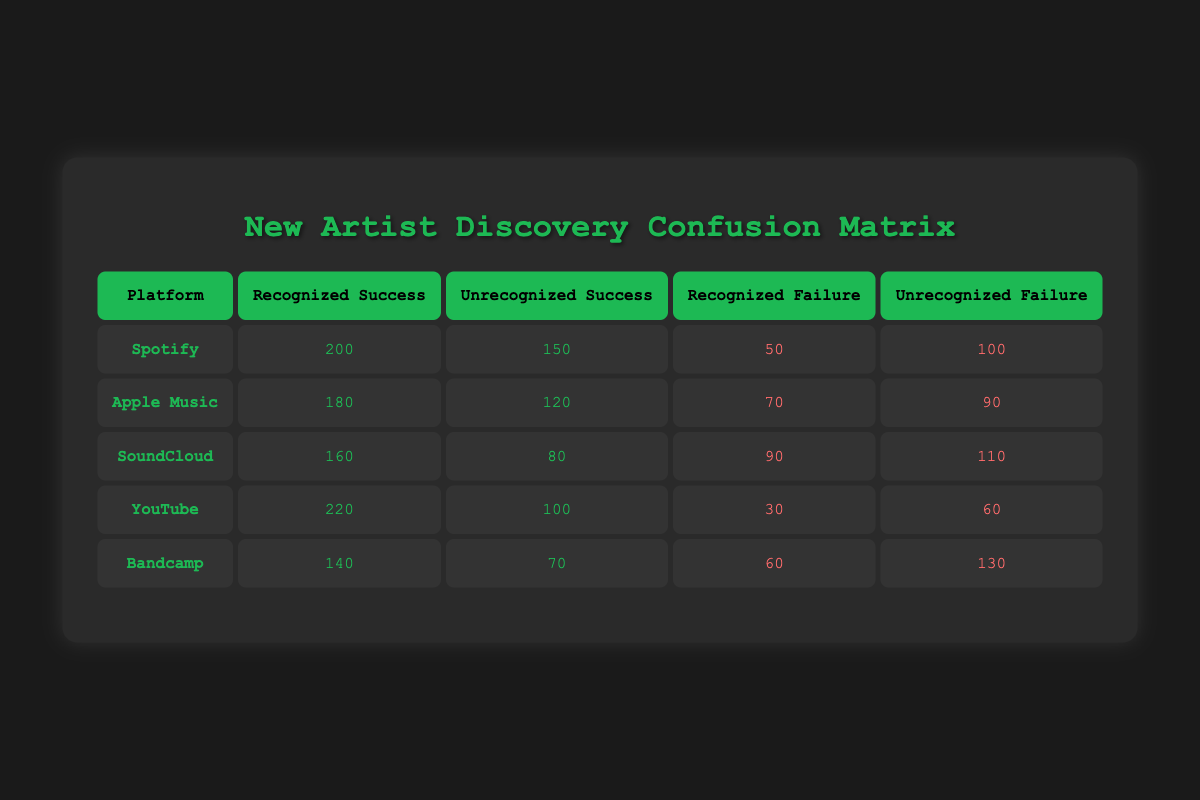What is the recognized success rate for Spotify? The recognized success for Spotify is 200, while the recognized failure is 50. To find the recognized success rate, divide recognized success by the total of recognized cases, which is 200/(200+50) = 200/250 = 0.8, meaning the recognized success rate for Spotify is 80%.
Answer: 80% How many total unsuccessful artist discoveries did Apple Music have? For Apple Music, recognized failure is 70 and unrecognized failure is 90. To find the total unsuccessful discoveries, add these two values: 70 + 90 = 160.
Answer: 160 Which platform had the highest number of recognized successful discoveries? Looking at the table, Spotify has 200 recognized successes, Apple Music has 180, SoundCloud has 160, YouTube has 220, and Bandcamp has 140. YouTube has the highest number at 220 recognized successes.
Answer: YouTube What is the average number of unrecognized successes across all platforms? To calculate the average for unrecognized successes, add all the unrecognized successes: 150 (Spotify) + 120 (Apple Music) + 80 (SoundCloud) + 100 (YouTube) + 70 (Bandcamp) = 620. There are 5 platforms, so divide the total by 5: 620/5 = 124.
Answer: 124 Is the total number of recognized failures for SoundCloud greater than the total number of unrecognized failures for any other platform? The recognized failures for SoundCloud are 90 and unrecognized failures are 110. Comparing with the other platforms: Spotify (150), Apple Music (90), YouTube (60), and Bandcamp (130), the total recognized failures for SoundCloud (90) is not greater than the unrecognized failures for Bandcamp (130).
Answer: No What is the sum of recognized successes and failures for Bandcamp? The recognized successes for Bandcamp are 140, and the recognized failures are 60. Thus, the sum is 140 + 60 = 200.
Answer: 200 Which platform had the lowest recognized success number? The recognized success numbers are: Spotify (200), Apple Music (180), SoundCloud (160), YouTube (220), and Bandcamp (140). Bandcamp has the lowest recognized success number at 140.
Answer: Bandcamp What is the ratio of total successes to total failures across all platforms? First, summarize the total successes: 200 + 150 (Spotify) + 180 + 120 (Apple Music) + 160 + 80 (SoundCloud) + 220 + 100 (YouTube) + 140 + 70 (Bandcamp) = 1100. Now summarize the total failures: 50 + 100 (Spotify) + 70 + 90 (Apple Music) + 90 + 110 (SoundCloud) + 30 + 60 (YouTube) + 60 + 130 (Bandcamp) = 740. The ratio is 1100:740 which simplifies to approximately 1.48.
Answer: 1.48 